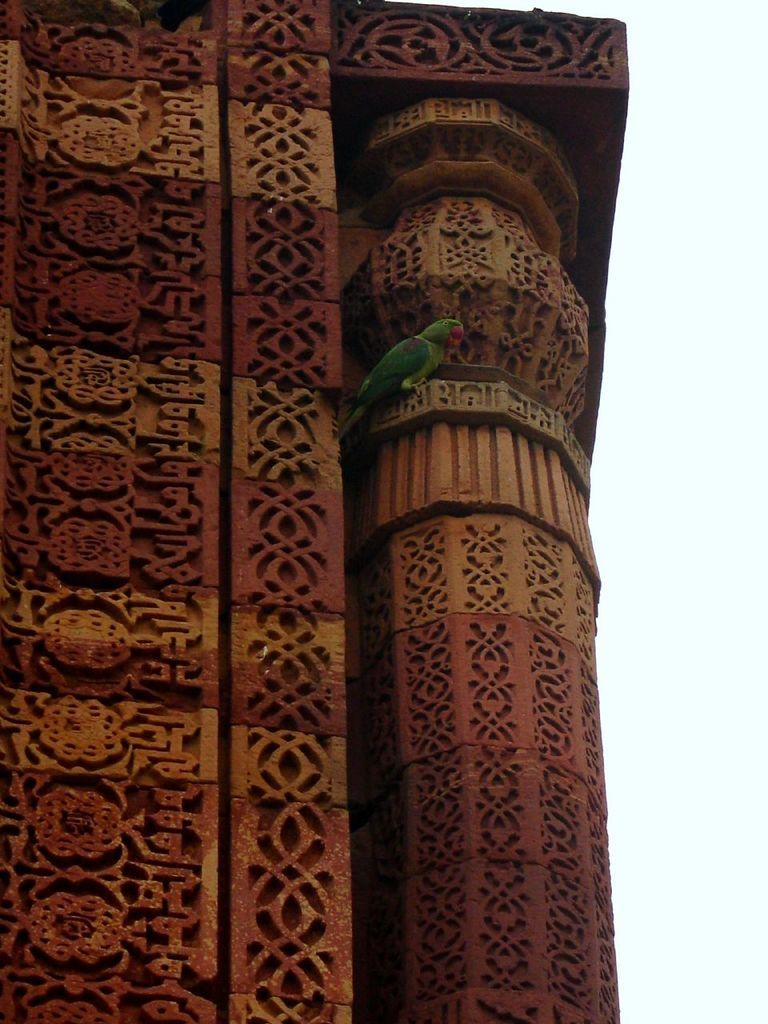What type of structure can be seen in the image? There is a monumental structure in the image. Where is the structure located? The structure is located over a place. Are there any animals present on the structure? Yes, there is a parrot present on the structure. What type of cream can be seen on the pancake in the image? There is no pancake or cream present in the image; it features a monumental structure with a parrot on it. 